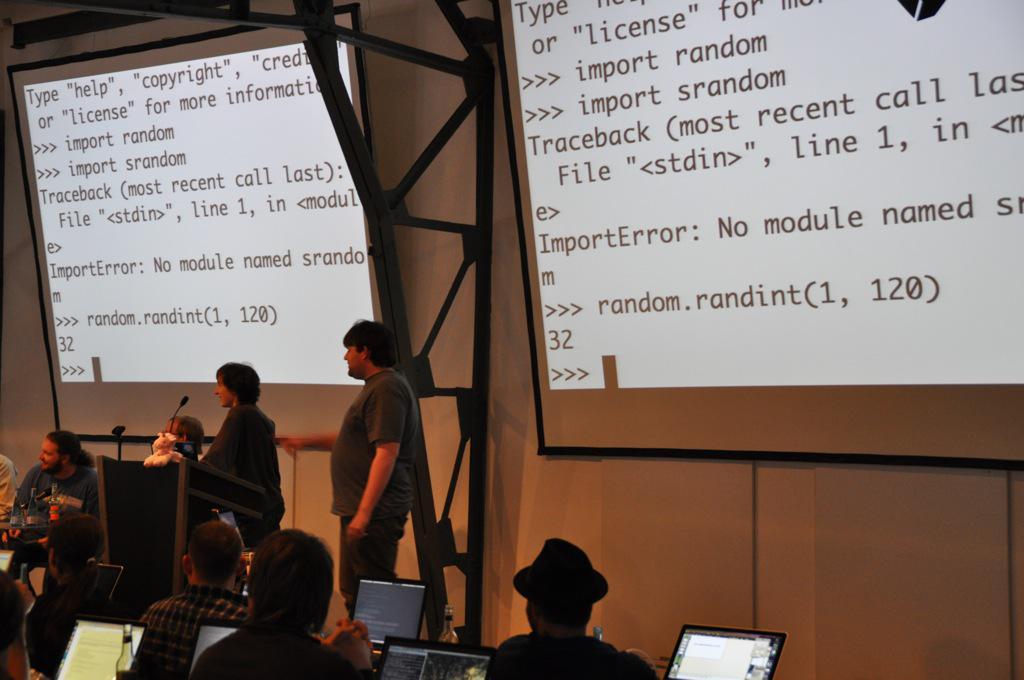Please provide a concise description of this image. This picture describes about group of people, few are seated and few are standing, in front of them we can see laptops, in the background we can find projector screens, microphones and metal rods. 